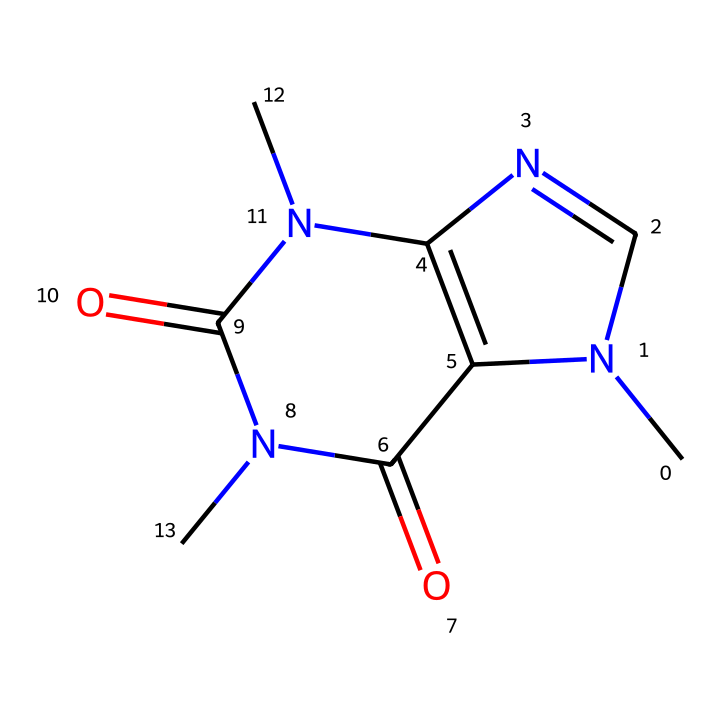What is the molecular formula of the caffeine molecule represented here? To determine the molecular formula, count the number of each type of atom present in the chemical structure. In the SMILES notation provided, the main components include carbon (C), nitrogen (N), and oxygen (O). After careful counting, the molecular formula is obtained as C8H10N4O2.
Answer: C8H10N4O2 How many rings are present in this caffeine structure? Examine the visual structure based on the SMILES. The structure consists of two interconnected aromatic rings, which can be counted to conclude that there are two rings in total.
Answer: 2 What type of functional groups are evident in the structure of caffeine? By analyzing the structure, we notice the presence of amine (NH) groups and carbonyl (C=O) groups. The nitrogen atoms in the rings indicate amine functionality while the double-bonded oxygen indicates carbonyl groups.
Answer: amine and carbonyl What is the primary source of this chemical in energy drinks? Based on the understanding of caffeine’s common sources, it is derived from natural sources like coffee beans, tea leaves, and cocoa beans, which are primary components in energy drinks.
Answer: coffee Does this caffeine structure suggest solubility in water? An evaluation of the structure shows that the presence of multiple nitrogen and oxygen atoms typically enhances water solubility due to polarity. Hence, caffeine is often categorized as water-soluble.
Answer: yes What characteristic typically makes caffeine a stimulant? The presence of certain nitrogen atoms in the structure, particularly in a cyclic configuration, contributes to its stimulant effect by influencing neurotransmitter activity in the brain.
Answer: cyclic nitrogen What aspect of this chemical structure contributes to its calming effects despite being a stimulant? This compound can compete with adenosine receptors due to its structural similarity, allowing it to inhibit the calming effects normally brought by adenosine, which is a neuromodulator.
Answer: adenosine receptors 